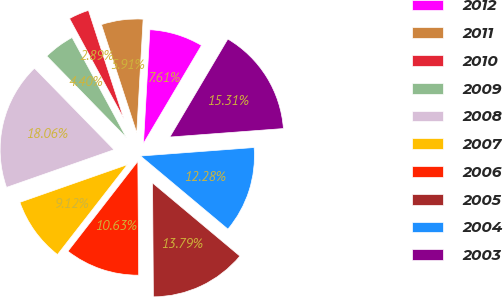<chart> <loc_0><loc_0><loc_500><loc_500><pie_chart><fcel>2012<fcel>2011<fcel>2010<fcel>2009<fcel>2008<fcel>2007<fcel>2006<fcel>2005<fcel>2004<fcel>2003<nl><fcel>7.61%<fcel>5.91%<fcel>2.89%<fcel>4.4%<fcel>18.06%<fcel>9.12%<fcel>10.63%<fcel>13.79%<fcel>12.28%<fcel>15.31%<nl></chart> 